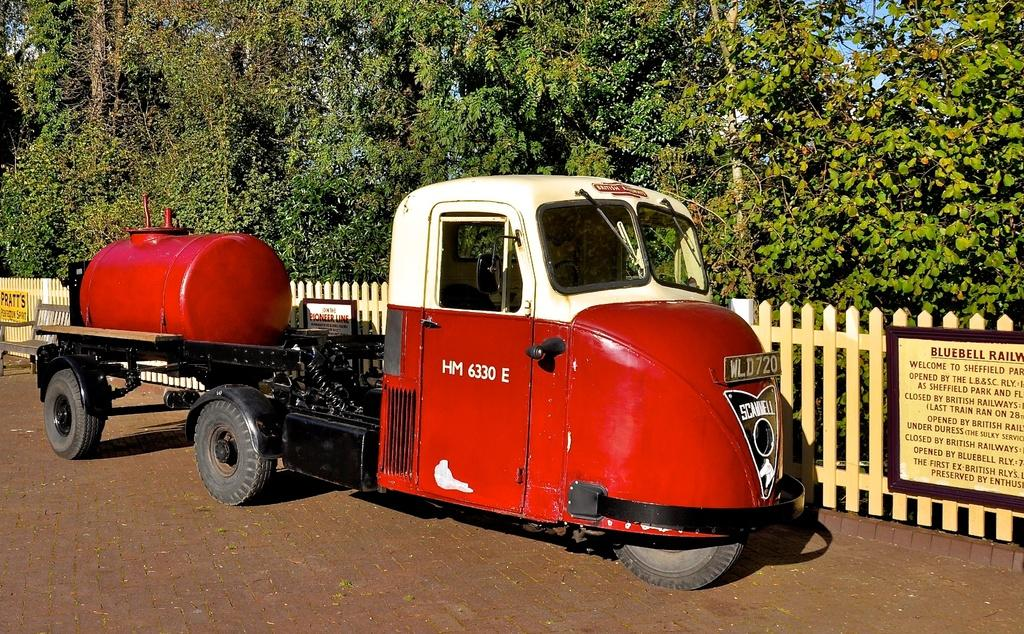What is the main subject of the image? There is a vehicle in the image. What colors can be seen on the vehicle? The vehicle has white and red colors. What can be seen in the background of the image? There is fencing, boards, and trees with green color in the background of the image. What is the color of the sky in the image? The sky is blue in the image. Can you tell me which actor is holding the fork in the image? There is no actor or fork present in the image; it features a vehicle and its surroundings. How many feet are visible in the image? There are no feet visible in the image; it focuses on a vehicle and its surroundings. 